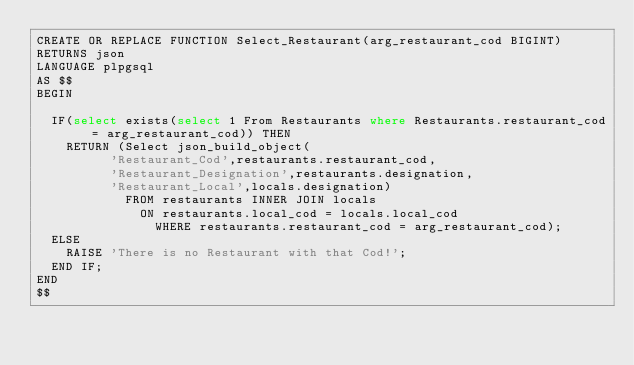Convert code to text. <code><loc_0><loc_0><loc_500><loc_500><_SQL_>CREATE OR REPLACE FUNCTION Select_Restaurant(arg_restaurant_cod BIGINT)
RETURNS json
LANGUAGE plpgsql
AS $$
BEGIN
	
	IF(select exists(select 1 From Restaurants where Restaurants.restaurant_cod = arg_restaurant_cod)) THEN
		RETURN (Select json_build_object(
					'Restaurant_Cod',restaurants.restaurant_cod, 
					'Restaurant_Designation',restaurants.designation, 
					'Restaurant_Local',locals.designation) 
						FROM restaurants INNER JOIN locals
							ON restaurants.local_cod = locals.local_cod
								WHERE restaurants.restaurant_cod = arg_restaurant_cod);
	ELSE
		RAISE 'There is no Restaurant with that Cod!';
	END IF;
END
$$</code> 